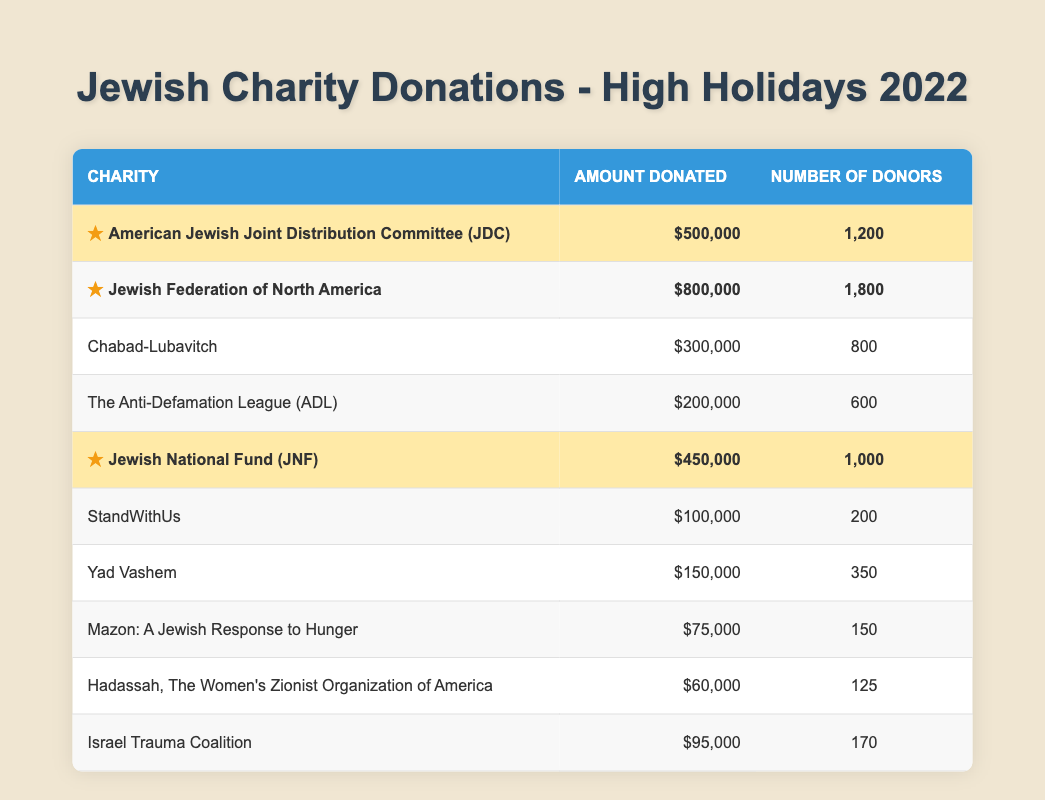What was the highest amount donated to a charity? The highest amount donated is $800,000 to the Jewish Federation of North America, as seen in the table.
Answer: $800,000 How many donors contributed to the American Jewish Joint Distribution Committee (JDC)? The table shows that 1,200 donors contributed to the American Jewish Joint Distribution Committee (JDC).
Answer: 1,200 Which charity received the least amount in donations? The charity with the least amount donated is Hadassah, with a donation of $60,000, according to the table.
Answer: $60,000 What is the total amount donated to all charities listed? Adding the amounts donated: 500,000 + 800,000 + 300,000 + 200,000 + 450,000 + 100,000 + 150,000 + 75,000 + 60,000 + 95,000 gives a total of $2,730,000.
Answer: $2,730,000 Is the Jewish National Fund (JNF) highlighted in the table? Yes, the Jewish National Fund (JNF) is marked as highlighted in the table, indicating significant donations.
Answer: Yes How many more donors contributed to the Jewish Federation of North America compared to the Jewish National Fund (JNF)? The Jewish Federation has 1,800 donors, while the JNF has 1,000 donors. The difference is 1,800 - 1,000 = 800 donors.
Answer: 800 If we combine the donations of the highlighted charities, what is the total? The highlighted charities are JDC ($500,000), Jewish Federation ($800,000), and JNF ($450,000). Their total is 500,000 + 800,000 + 450,000 = $1,750,000.
Answer: $1,750,000 How many charities received a donation greater than $300,000? Reviewing the table, 4 charities received donations greater than $300,000: JDC, Jewish Federation, JNF, and Chabad-Lubavitch.
Answer: 4 What percentage of the total donations came from the Jewish Federation of North America? The Jewish Federation donated $800,000 out of a total of $2,730,000. The percentage is (800,000 / 2,730,000) * 100 ≈ 29.32%.
Answer: 29.32% How many donors are there in total across all charities? The total number of donors across all charities can be calculated by summing: 1200 + 1800 + 800 + 600 + 1000 + 200 + 350 + 150 + 125 + 170 = 5,195 donors.
Answer: 5,195 